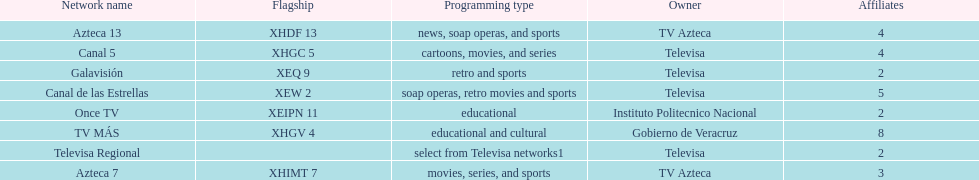How many networks show soap operas? 2. 